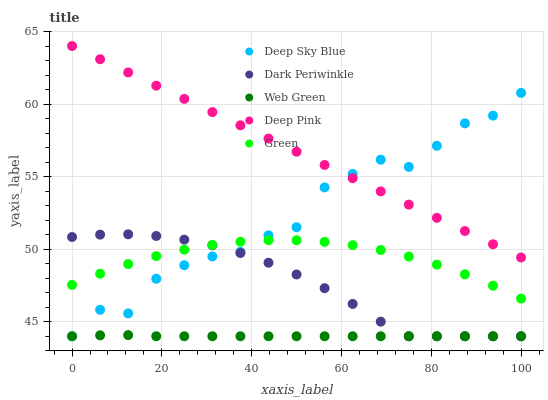Does Web Green have the minimum area under the curve?
Answer yes or no. Yes. Does Deep Pink have the maximum area under the curve?
Answer yes or no. Yes. Does Green have the minimum area under the curve?
Answer yes or no. No. Does Green have the maximum area under the curve?
Answer yes or no. No. Is Deep Pink the smoothest?
Answer yes or no. Yes. Is Deep Sky Blue the roughest?
Answer yes or no. Yes. Is Green the smoothest?
Answer yes or no. No. Is Green the roughest?
Answer yes or no. No. Does Web Green have the lowest value?
Answer yes or no. Yes. Does Green have the lowest value?
Answer yes or no. No. Does Deep Pink have the highest value?
Answer yes or no. Yes. Does Green have the highest value?
Answer yes or no. No. Is Web Green less than Green?
Answer yes or no. Yes. Is Deep Pink greater than Green?
Answer yes or no. Yes. Does Deep Sky Blue intersect Green?
Answer yes or no. Yes. Is Deep Sky Blue less than Green?
Answer yes or no. No. Is Deep Sky Blue greater than Green?
Answer yes or no. No. Does Web Green intersect Green?
Answer yes or no. No. 